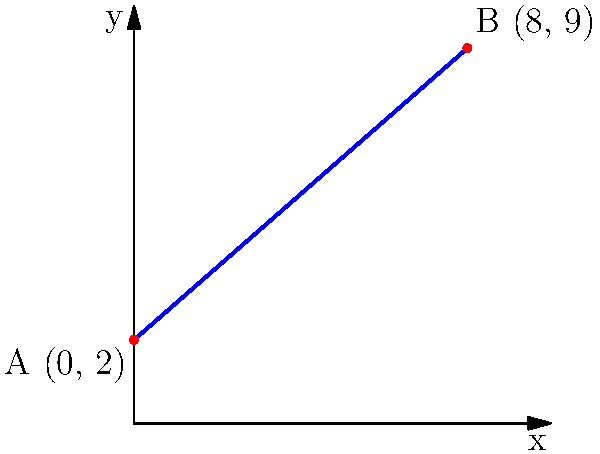During one of the squirrel's exciting adventures, it climbed a steep hill. The squirrel started climbing at point A (0, 2) and reached the top at point B (8, 9). Can you help calculate the slope of this hill? Let's solve this step-by-step:

1) The slope of a line can be calculated using the formula:

   $$ m = \frac{y_2 - y_1}{x_2 - x_1} $$

   where $(x_1, y_1)$ is the starting point and $(x_2, y_2)$ is the ending point.

2) In this case:
   - Starting point A: $(x_1, y_1) = (0, 2)$
   - Ending point B: $(x_2, y_2) = (8, 9)$

3) Let's plug these values into our formula:

   $$ m = \frac{9 - 2}{8 - 0} = \frac{7}{8} $$

4) Simplify:
   
   $$ m = \frac{7}{8} = 0.875 $$

So, the slope of the hill is $\frac{7}{8}$ or 0.875.
Answer: $\frac{7}{8}$ 